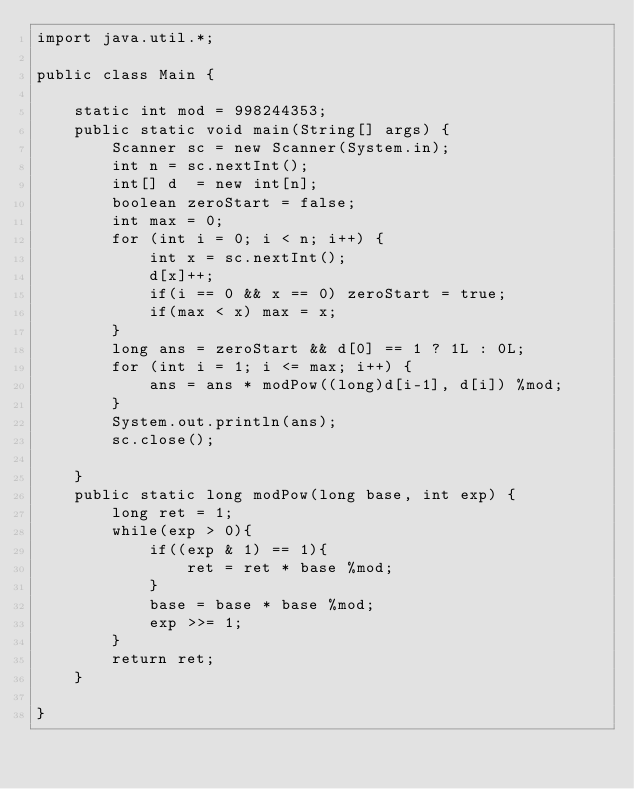Convert code to text. <code><loc_0><loc_0><loc_500><loc_500><_Java_>import java.util.*;

public class Main {

    static int mod = 998244353;
    public static void main(String[] args) {
        Scanner sc = new Scanner(System.in);
        int n = sc.nextInt();
        int[] d  = new int[n];
        boolean zeroStart = false;
        int max = 0;
        for (int i = 0; i < n; i++) {
            int x = sc.nextInt();
            d[x]++;
            if(i == 0 && x == 0) zeroStart = true;
            if(max < x) max = x;
        }
        long ans = zeroStart && d[0] == 1 ? 1L : 0L;
        for (int i = 1; i <= max; i++) {
            ans = ans * modPow((long)d[i-1], d[i]) %mod;
        }
        System.out.println(ans);
        sc.close();

    }
    public static long modPow(long base, int exp) {
        long ret = 1;
        while(exp > 0){
            if((exp & 1) == 1){
                ret = ret * base %mod;
            }
            base = base * base %mod;
            exp >>= 1;
        }
        return ret;
    }

}
</code> 